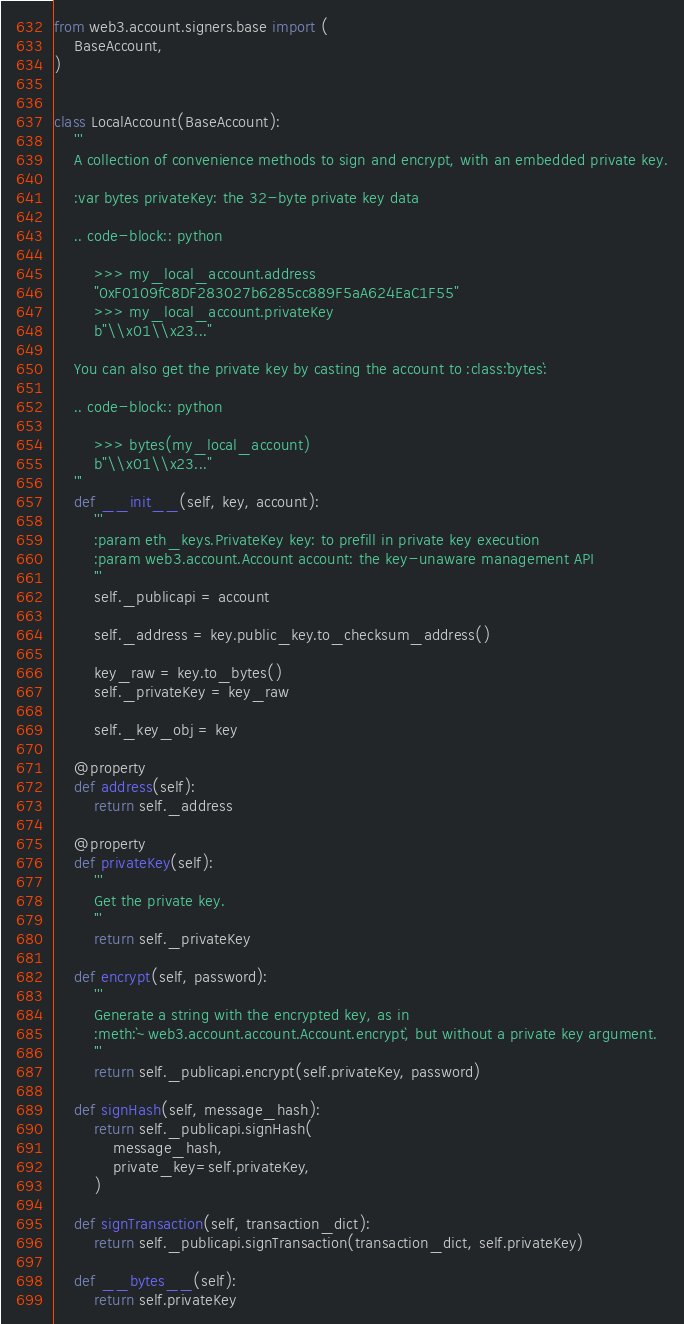Convert code to text. <code><loc_0><loc_0><loc_500><loc_500><_Python_>from web3.account.signers.base import (
    BaseAccount,
)


class LocalAccount(BaseAccount):
    '''
    A collection of convenience methods to sign and encrypt, with an embedded private key.

    :var bytes privateKey: the 32-byte private key data

    .. code-block:: python

        >>> my_local_account.address
        "0xF0109fC8DF283027b6285cc889F5aA624EaC1F55"
        >>> my_local_account.privateKey
        b"\\x01\\x23..."

    You can also get the private key by casting the account to :class:`bytes`:

    .. code-block:: python

        >>> bytes(my_local_account)
        b"\\x01\\x23..."
    '''
    def __init__(self, key, account):
        '''
        :param eth_keys.PrivateKey key: to prefill in private key execution
        :param web3.account.Account account: the key-unaware management API
        '''
        self._publicapi = account

        self._address = key.public_key.to_checksum_address()

        key_raw = key.to_bytes()
        self._privateKey = key_raw

        self._key_obj = key

    @property
    def address(self):
        return self._address

    @property
    def privateKey(self):
        '''
        Get the private key.
        '''
        return self._privateKey

    def encrypt(self, password):
        '''
        Generate a string with the encrypted key, as in
        :meth:`~web3.account.account.Account.encrypt`, but without a private key argument.
        '''
        return self._publicapi.encrypt(self.privateKey, password)

    def signHash(self, message_hash):
        return self._publicapi.signHash(
            message_hash,
            private_key=self.privateKey,
        )

    def signTransaction(self, transaction_dict):
        return self._publicapi.signTransaction(transaction_dict, self.privateKey)

    def __bytes__(self):
        return self.privateKey
</code> 